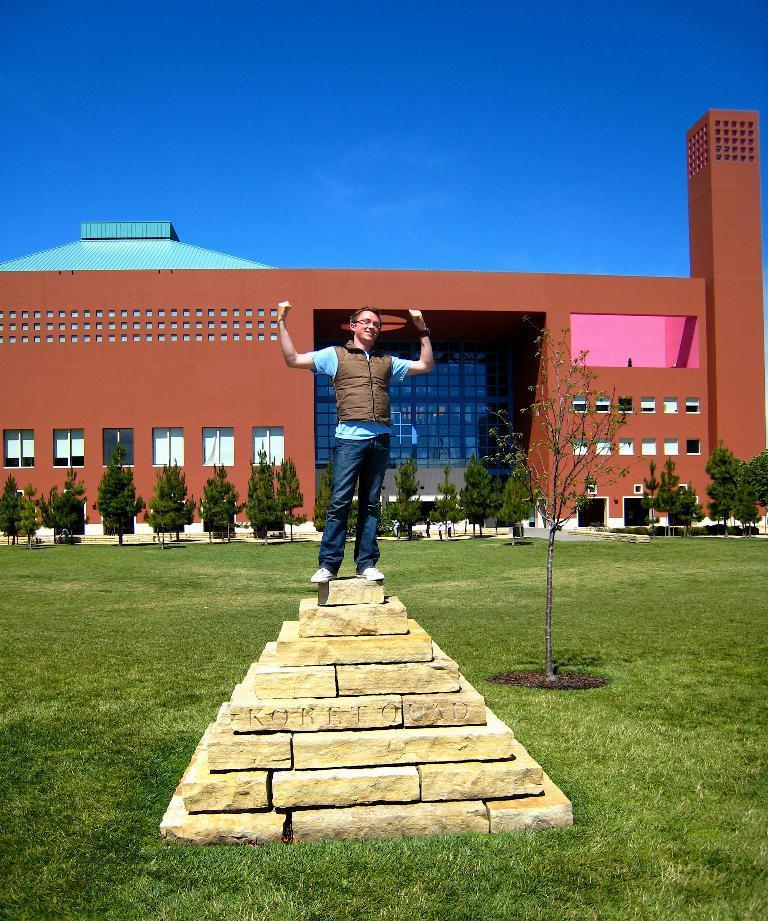Describe this image in one or two sentences. In this image I can see a man standing on the pyramid which is on the grass, at the back there are some trees and building. 